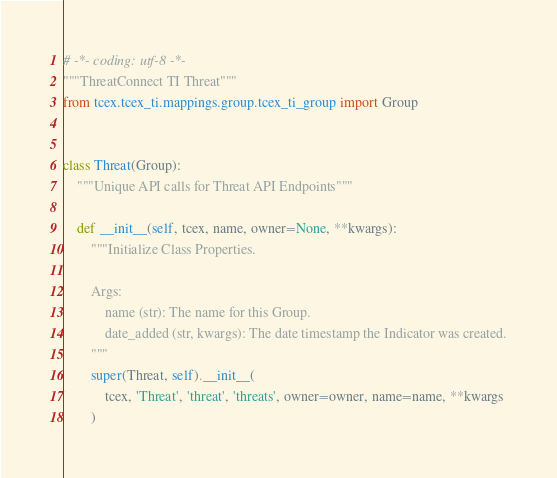Convert code to text. <code><loc_0><loc_0><loc_500><loc_500><_Python_># -*- coding: utf-8 -*-
"""ThreatConnect TI Threat"""
from tcex.tcex_ti.mappings.group.tcex_ti_group import Group


class Threat(Group):
    """Unique API calls for Threat API Endpoints"""

    def __init__(self, tcex, name, owner=None, **kwargs):
        """Initialize Class Properties.

        Args:
            name (str): The name for this Group.
            date_added (str, kwargs): The date timestamp the Indicator was created.
        """
        super(Threat, self).__init__(
            tcex, 'Threat', 'threat', 'threats', owner=owner, name=name, **kwargs
        )
</code> 